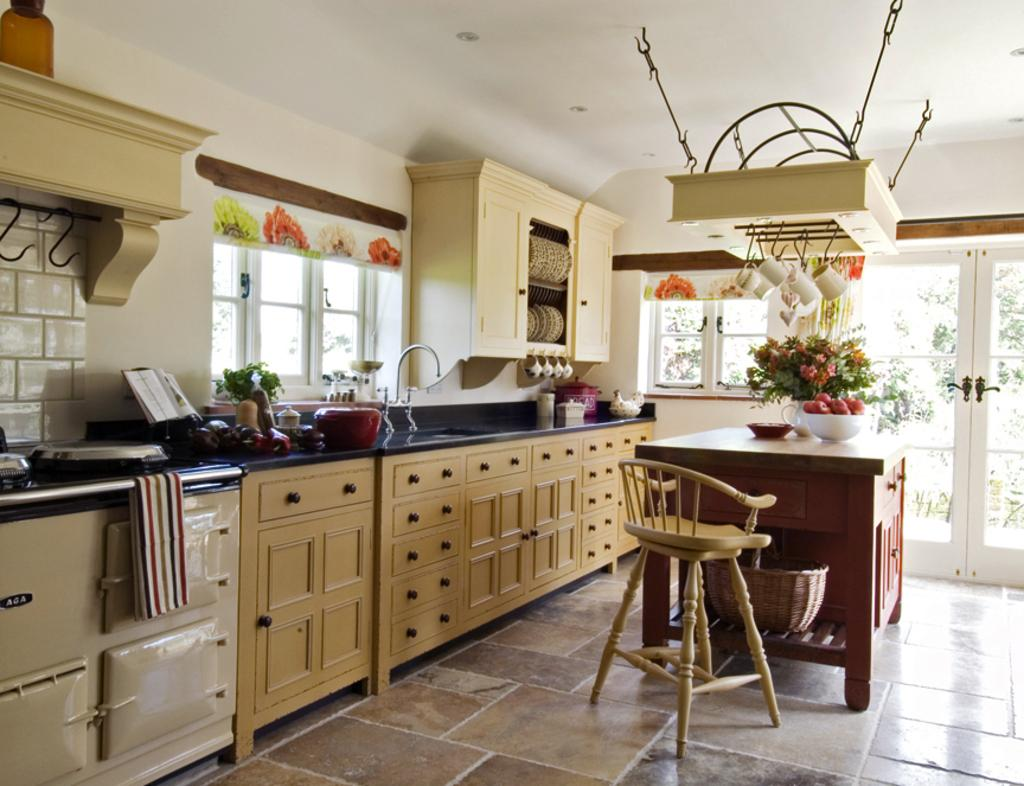What type of furniture is present in the image? There is a chair in the image. What is on the table in the image? There is a table with items on it in the image. What type of dishware can be seen in the image? There are cups in the image. What type of storage units are present in the image? There are cabinets in the image. What allows natural light into the room in the image? There are windows in the image. What separates the interior of the room from the exterior in the image? There is a wall in the image. What type of star can be seen shining through the glass in the image? There is no star or glass present in the image. What force is causing the items on the table to levitate in the image? There is no indication of any items levitating or any force causing them to do so in the image. 